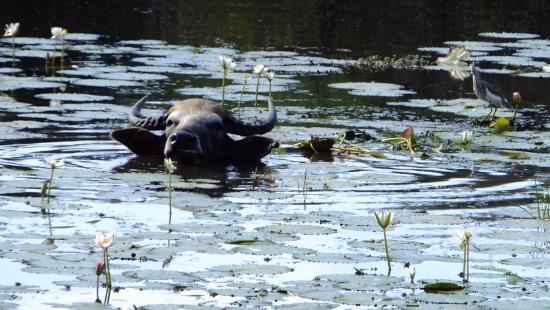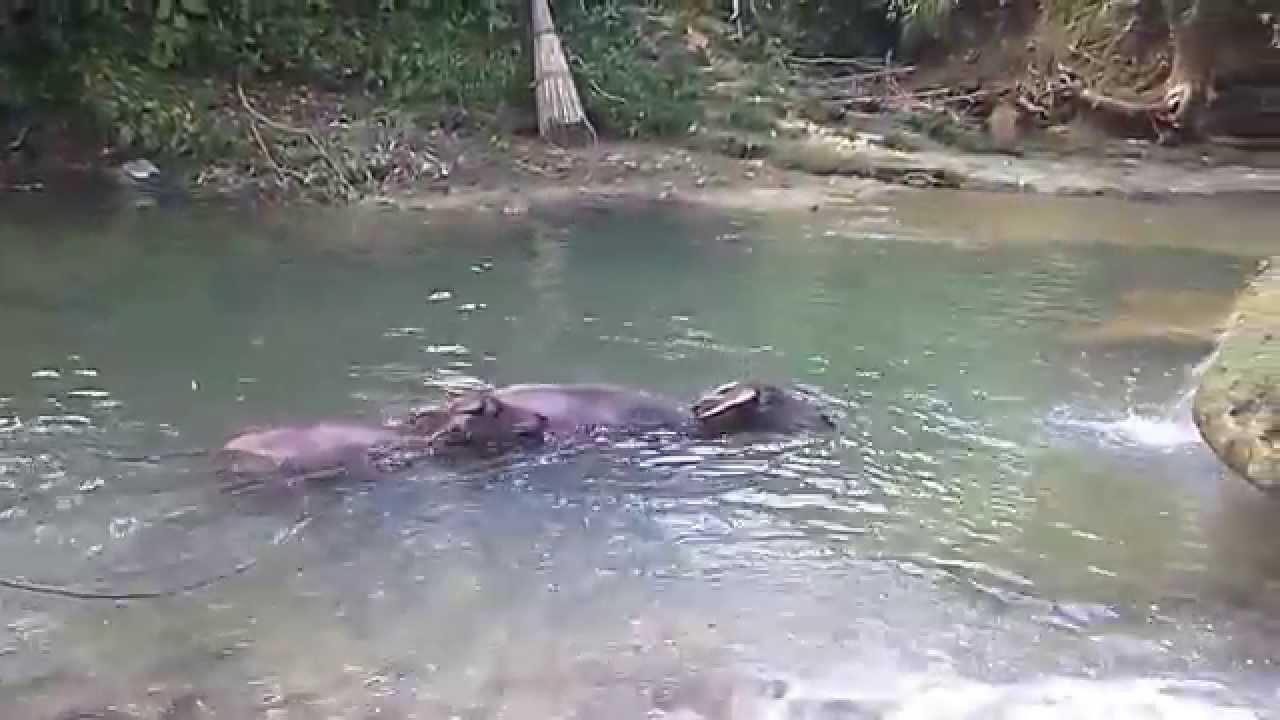The first image is the image on the left, the second image is the image on the right. Analyze the images presented: Is the assertion "The left image contains no more than one water buffalo swimming in water." valid? Answer yes or no. Yes. The first image is the image on the left, the second image is the image on the right. Assess this claim about the two images: "The combined images contain no more than three water buffalo, all of them in water to their chins.". Correct or not? Answer yes or no. Yes. 